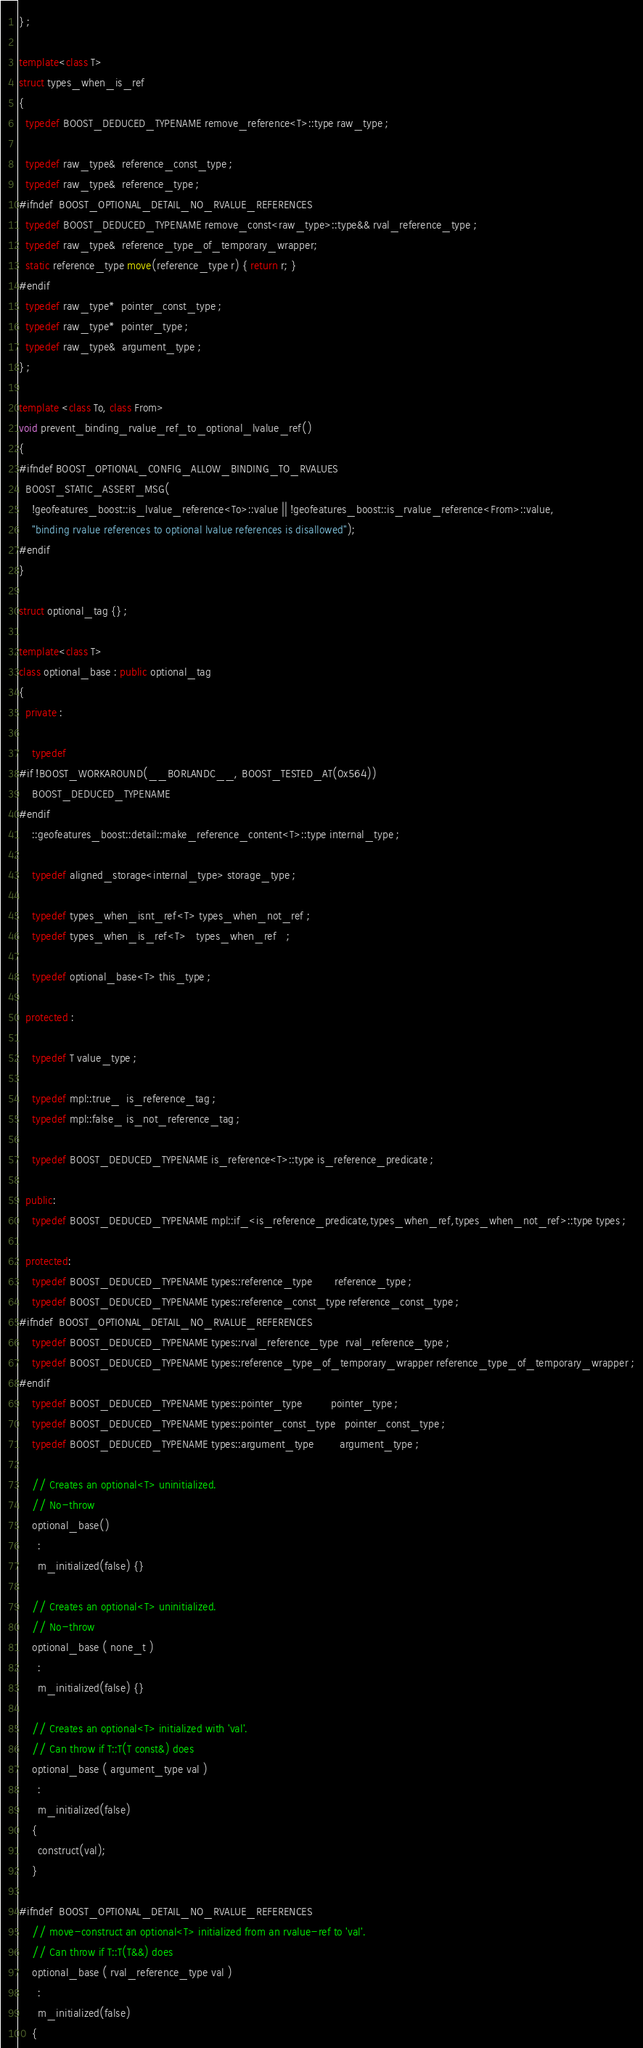Convert code to text. <code><loc_0><loc_0><loc_500><loc_500><_C++_>} ;

template<class T>
struct types_when_is_ref
{
  typedef BOOST_DEDUCED_TYPENAME remove_reference<T>::type raw_type ;

  typedef raw_type&  reference_const_type ;
  typedef raw_type&  reference_type ;
#ifndef  BOOST_OPTIONAL_DETAIL_NO_RVALUE_REFERENCES
  typedef BOOST_DEDUCED_TYPENAME remove_const<raw_type>::type&& rval_reference_type ;
  typedef raw_type&  reference_type_of_temporary_wrapper;
  static reference_type move(reference_type r) { return r; }
#endif
  typedef raw_type*  pointer_const_type ;
  typedef raw_type*  pointer_type ;
  typedef raw_type&  argument_type ;
} ;

template <class To, class From>
void prevent_binding_rvalue_ref_to_optional_lvalue_ref()
{
#ifndef BOOST_OPTIONAL_CONFIG_ALLOW_BINDING_TO_RVALUES
  BOOST_STATIC_ASSERT_MSG(
    !geofeatures_boost::is_lvalue_reference<To>::value || !geofeatures_boost::is_rvalue_reference<From>::value, 
    "binding rvalue references to optional lvalue references is disallowed");
#endif    
}

struct optional_tag {} ;

template<class T>
class optional_base : public optional_tag
{
  private :

    typedef
#if !BOOST_WORKAROUND(__BORLANDC__, BOOST_TESTED_AT(0x564))
    BOOST_DEDUCED_TYPENAME
#endif
    ::geofeatures_boost::detail::make_reference_content<T>::type internal_type ;

    typedef aligned_storage<internal_type> storage_type ;

    typedef types_when_isnt_ref<T> types_when_not_ref ;
    typedef types_when_is_ref<T>   types_when_ref   ;

    typedef optional_base<T> this_type ;

  protected :

    typedef T value_type ;

    typedef mpl::true_  is_reference_tag ;
    typedef mpl::false_ is_not_reference_tag ;

    typedef BOOST_DEDUCED_TYPENAME is_reference<T>::type is_reference_predicate ;

  public:
    typedef BOOST_DEDUCED_TYPENAME mpl::if_<is_reference_predicate,types_when_ref,types_when_not_ref>::type types ;

  protected:
    typedef BOOST_DEDUCED_TYPENAME types::reference_type       reference_type ;
    typedef BOOST_DEDUCED_TYPENAME types::reference_const_type reference_const_type ;
#ifndef  BOOST_OPTIONAL_DETAIL_NO_RVALUE_REFERENCES
    typedef BOOST_DEDUCED_TYPENAME types::rval_reference_type  rval_reference_type ;
    typedef BOOST_DEDUCED_TYPENAME types::reference_type_of_temporary_wrapper reference_type_of_temporary_wrapper ;
#endif
    typedef BOOST_DEDUCED_TYPENAME types::pointer_type         pointer_type ;
    typedef BOOST_DEDUCED_TYPENAME types::pointer_const_type   pointer_const_type ;
    typedef BOOST_DEDUCED_TYPENAME types::argument_type        argument_type ;

    // Creates an optional<T> uninitialized.
    // No-throw
    optional_base()
      :
      m_initialized(false) {}

    // Creates an optional<T> uninitialized.
    // No-throw
    optional_base ( none_t )
      :
      m_initialized(false) {}

    // Creates an optional<T> initialized with 'val'.
    // Can throw if T::T(T const&) does
    optional_base ( argument_type val )
      :
      m_initialized(false)
    {
      construct(val);
    }

#ifndef  BOOST_OPTIONAL_DETAIL_NO_RVALUE_REFERENCES
    // move-construct an optional<T> initialized from an rvalue-ref to 'val'.
    // Can throw if T::T(T&&) does
    optional_base ( rval_reference_type val )
      :
      m_initialized(false)
    {</code> 